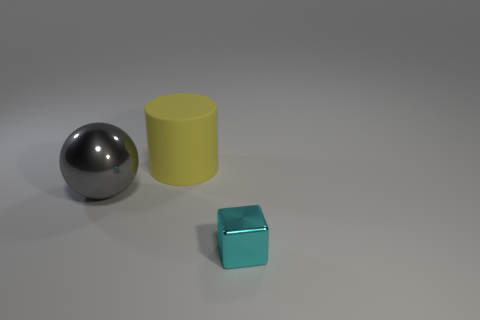Is the material of the cyan block on the right side of the big rubber thing the same as the object that is left of the cylinder?
Provide a short and direct response. Yes. There is a shiny object that is the same size as the cylinder; what color is it?
Provide a succinct answer. Gray. Is there anything else of the same color as the large matte thing?
Your answer should be very brief. No. There is a shiny object that is to the right of the big gray thing in front of the large thing behind the big gray ball; what is its size?
Make the answer very short. Small. What is the color of the thing that is in front of the large yellow cylinder and right of the gray metallic thing?
Make the answer very short. Cyan. There is a thing left of the large yellow cylinder; what is its size?
Your response must be concise. Large. What number of cyan things are made of the same material as the big sphere?
Offer a very short reply. 1. There is a metallic object that is in front of the big gray object; is its shape the same as the big metal thing?
Keep it short and to the point. No. What is the color of the other object that is made of the same material as the cyan thing?
Provide a short and direct response. Gray. Is there a metallic cube that is on the left side of the metallic object that is in front of the large thing left of the large matte cylinder?
Your answer should be compact. No. 